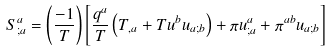<formula> <loc_0><loc_0><loc_500><loc_500>S _ { ; a } ^ { a } = \left ( \frac { - 1 } T \right ) \left [ \frac { q ^ { a } } T \left ( T _ { , a } + T u ^ { b } u _ { a ; b } \right ) + \pi u _ { ; a } ^ { a } + \pi ^ { a b } u _ { a ; b } \right ]</formula> 